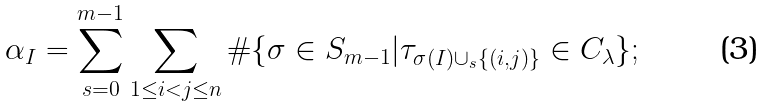<formula> <loc_0><loc_0><loc_500><loc_500>\alpha _ { I } = \sum _ { s = 0 } ^ { m - 1 } \sum _ { 1 \leq i < j \leq n } \# \{ \sigma \in S _ { m - 1 } | \tau _ { \sigma ( I ) \cup _ { s } \{ ( i , j ) \} } \in C _ { \lambda } \} ;</formula> 